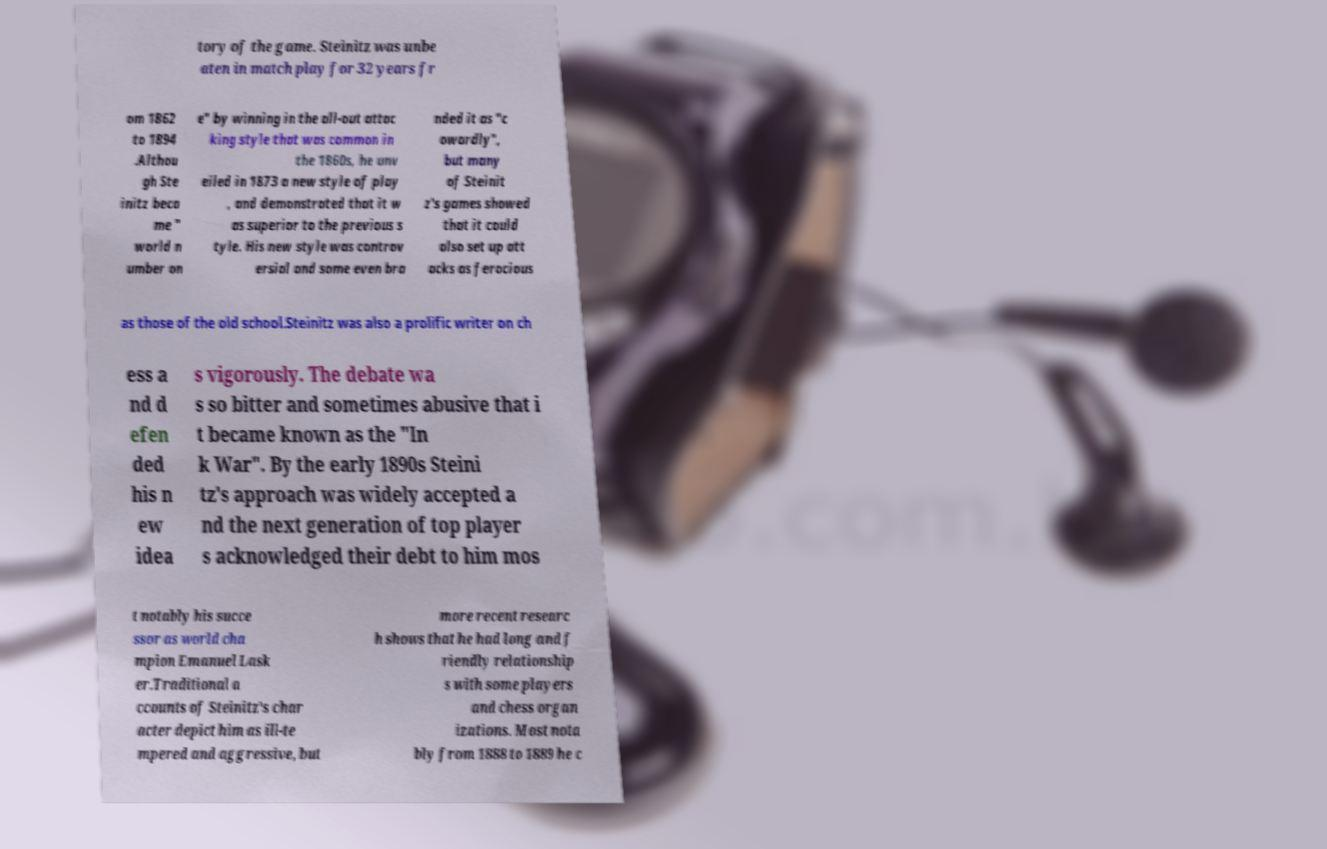Can you accurately transcribe the text from the provided image for me? tory of the game. Steinitz was unbe aten in match play for 32 years fr om 1862 to 1894 .Althou gh Ste initz beca me " world n umber on e" by winning in the all-out attac king style that was common in the 1860s, he unv eiled in 1873 a new style of play , and demonstrated that it w as superior to the previous s tyle. His new style was controv ersial and some even bra nded it as "c owardly", but many of Steinit z's games showed that it could also set up att acks as ferocious as those of the old school.Steinitz was also a prolific writer on ch ess a nd d efen ded his n ew idea s vigorously. The debate wa s so bitter and sometimes abusive that i t became known as the "In k War". By the early 1890s Steini tz's approach was widely accepted a nd the next generation of top player s acknowledged their debt to him mos t notably his succe ssor as world cha mpion Emanuel Lask er.Traditional a ccounts of Steinitz's char acter depict him as ill-te mpered and aggressive, but more recent researc h shows that he had long and f riendly relationship s with some players and chess organ izations. Most nota bly from 1888 to 1889 he c 